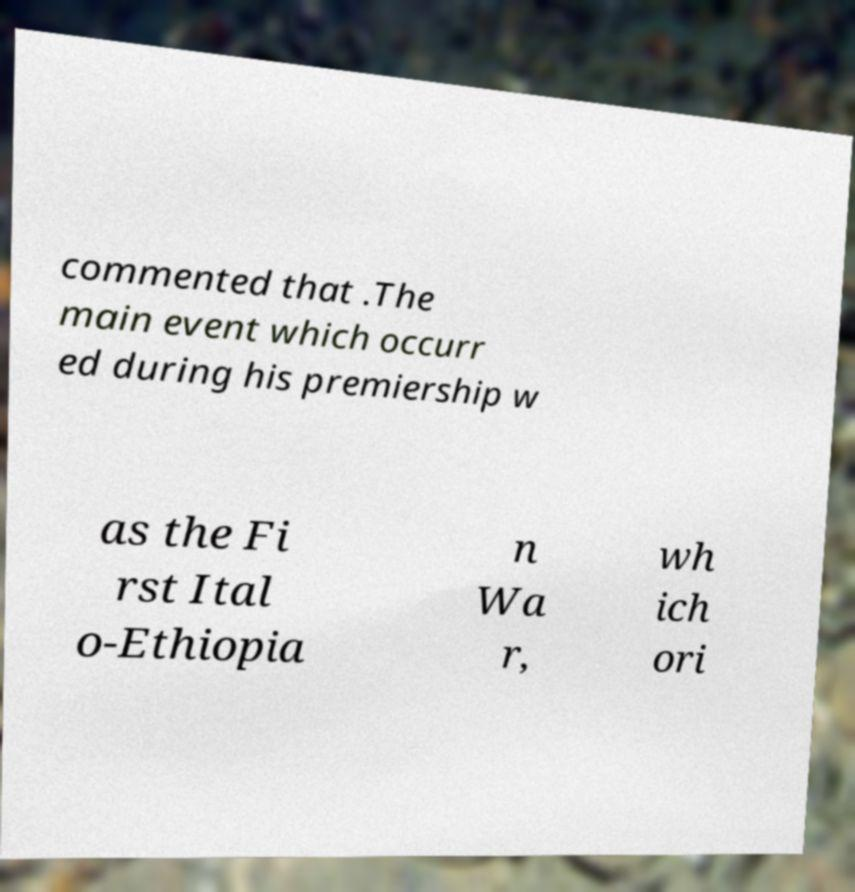Can you accurately transcribe the text from the provided image for me? commented that .The main event which occurr ed during his premiership w as the Fi rst Ital o-Ethiopia n Wa r, wh ich ori 